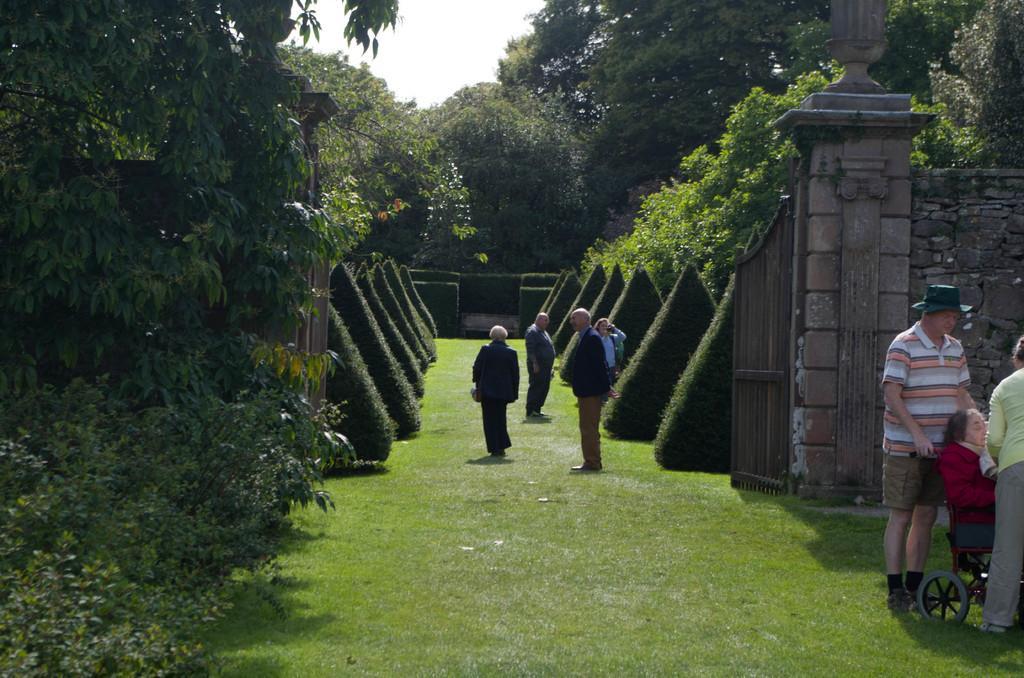Describe this image in one or two sentences. In the middle of the picture, we see people are standing. On either side of them, we see shrubs. On the right side, we see a woman in the red jacket is on the wheelchair. Beside her, we see two people are standing. Behind them, we see a pillar and a wall which is made up of stones. Beside that, we see a gate. At the bottom of the picture, we see the grass. On the left side, there are trees. In the background, we see the trees. At the top, we see the sky. 